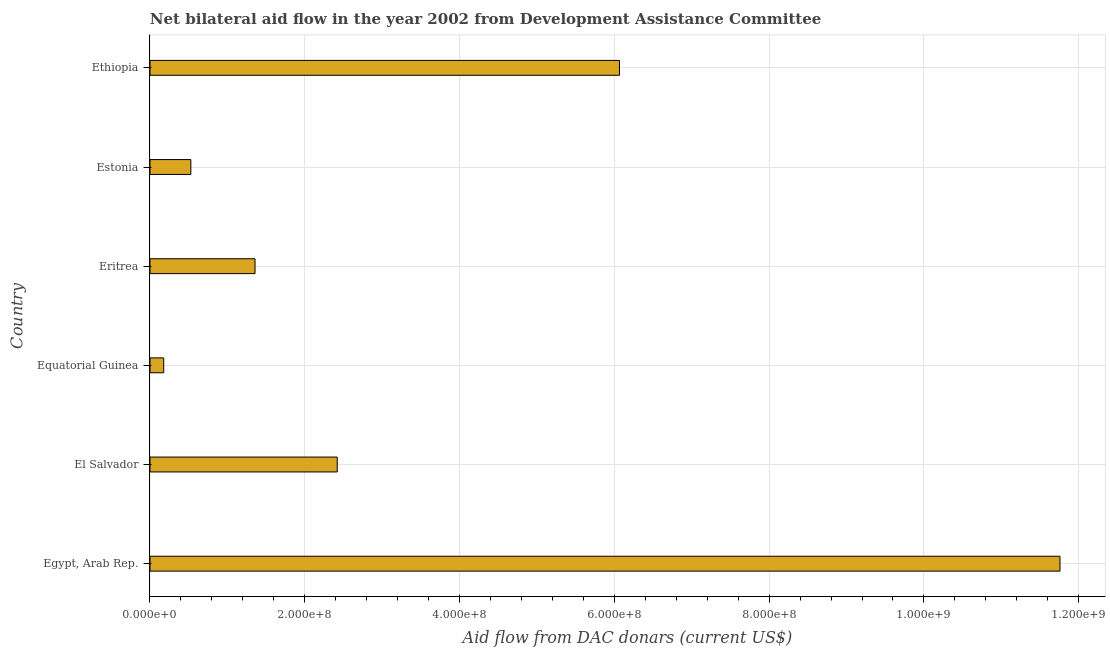What is the title of the graph?
Your response must be concise. Net bilateral aid flow in the year 2002 from Development Assistance Committee. What is the label or title of the X-axis?
Provide a short and direct response. Aid flow from DAC donars (current US$). What is the net bilateral aid flows from dac donors in Ethiopia?
Keep it short and to the point. 6.07e+08. Across all countries, what is the maximum net bilateral aid flows from dac donors?
Provide a succinct answer. 1.18e+09. Across all countries, what is the minimum net bilateral aid flows from dac donors?
Offer a terse response. 1.77e+07. In which country was the net bilateral aid flows from dac donors maximum?
Provide a short and direct response. Egypt, Arab Rep. In which country was the net bilateral aid flows from dac donors minimum?
Give a very brief answer. Equatorial Guinea. What is the sum of the net bilateral aid flows from dac donors?
Offer a terse response. 2.23e+09. What is the difference between the net bilateral aid flows from dac donors in Equatorial Guinea and Estonia?
Give a very brief answer. -3.50e+07. What is the average net bilateral aid flows from dac donors per country?
Keep it short and to the point. 3.72e+08. What is the median net bilateral aid flows from dac donors?
Ensure brevity in your answer.  1.89e+08. What is the ratio of the net bilateral aid flows from dac donors in Equatorial Guinea to that in Eritrea?
Your answer should be very brief. 0.13. What is the difference between the highest and the second highest net bilateral aid flows from dac donors?
Your response must be concise. 5.69e+08. What is the difference between the highest and the lowest net bilateral aid flows from dac donors?
Your response must be concise. 1.16e+09. In how many countries, is the net bilateral aid flows from dac donors greater than the average net bilateral aid flows from dac donors taken over all countries?
Keep it short and to the point. 2. Are all the bars in the graph horizontal?
Offer a very short reply. Yes. How many countries are there in the graph?
Your answer should be compact. 6. What is the Aid flow from DAC donars (current US$) of Egypt, Arab Rep.?
Make the answer very short. 1.18e+09. What is the Aid flow from DAC donars (current US$) of El Salvador?
Offer a very short reply. 2.42e+08. What is the Aid flow from DAC donars (current US$) in Equatorial Guinea?
Offer a very short reply. 1.77e+07. What is the Aid flow from DAC donars (current US$) of Eritrea?
Give a very brief answer. 1.36e+08. What is the Aid flow from DAC donars (current US$) in Estonia?
Your answer should be very brief. 5.28e+07. What is the Aid flow from DAC donars (current US$) in Ethiopia?
Your answer should be very brief. 6.07e+08. What is the difference between the Aid flow from DAC donars (current US$) in Egypt, Arab Rep. and El Salvador?
Offer a very short reply. 9.34e+08. What is the difference between the Aid flow from DAC donars (current US$) in Egypt, Arab Rep. and Equatorial Guinea?
Keep it short and to the point. 1.16e+09. What is the difference between the Aid flow from DAC donars (current US$) in Egypt, Arab Rep. and Eritrea?
Make the answer very short. 1.04e+09. What is the difference between the Aid flow from DAC donars (current US$) in Egypt, Arab Rep. and Estonia?
Keep it short and to the point. 1.12e+09. What is the difference between the Aid flow from DAC donars (current US$) in Egypt, Arab Rep. and Ethiopia?
Provide a succinct answer. 5.69e+08. What is the difference between the Aid flow from DAC donars (current US$) in El Salvador and Equatorial Guinea?
Offer a terse response. 2.24e+08. What is the difference between the Aid flow from DAC donars (current US$) in El Salvador and Eritrea?
Offer a very short reply. 1.06e+08. What is the difference between the Aid flow from DAC donars (current US$) in El Salvador and Estonia?
Your response must be concise. 1.89e+08. What is the difference between the Aid flow from DAC donars (current US$) in El Salvador and Ethiopia?
Your answer should be very brief. -3.65e+08. What is the difference between the Aid flow from DAC donars (current US$) in Equatorial Guinea and Eritrea?
Ensure brevity in your answer.  -1.18e+08. What is the difference between the Aid flow from DAC donars (current US$) in Equatorial Guinea and Estonia?
Give a very brief answer. -3.50e+07. What is the difference between the Aid flow from DAC donars (current US$) in Equatorial Guinea and Ethiopia?
Ensure brevity in your answer.  -5.89e+08. What is the difference between the Aid flow from DAC donars (current US$) in Eritrea and Estonia?
Your response must be concise. 8.29e+07. What is the difference between the Aid flow from DAC donars (current US$) in Eritrea and Ethiopia?
Your answer should be compact. -4.71e+08. What is the difference between the Aid flow from DAC donars (current US$) in Estonia and Ethiopia?
Give a very brief answer. -5.54e+08. What is the ratio of the Aid flow from DAC donars (current US$) in Egypt, Arab Rep. to that in El Salvador?
Offer a very short reply. 4.86. What is the ratio of the Aid flow from DAC donars (current US$) in Egypt, Arab Rep. to that in Equatorial Guinea?
Ensure brevity in your answer.  66.32. What is the ratio of the Aid flow from DAC donars (current US$) in Egypt, Arab Rep. to that in Eritrea?
Offer a terse response. 8.66. What is the ratio of the Aid flow from DAC donars (current US$) in Egypt, Arab Rep. to that in Estonia?
Offer a terse response. 22.28. What is the ratio of the Aid flow from DAC donars (current US$) in Egypt, Arab Rep. to that in Ethiopia?
Your answer should be very brief. 1.94. What is the ratio of the Aid flow from DAC donars (current US$) in El Salvador to that in Equatorial Guinea?
Offer a terse response. 13.64. What is the ratio of the Aid flow from DAC donars (current US$) in El Salvador to that in Eritrea?
Offer a terse response. 1.78. What is the ratio of the Aid flow from DAC donars (current US$) in El Salvador to that in Estonia?
Offer a terse response. 4.58. What is the ratio of the Aid flow from DAC donars (current US$) in El Salvador to that in Ethiopia?
Provide a short and direct response. 0.4. What is the ratio of the Aid flow from DAC donars (current US$) in Equatorial Guinea to that in Eritrea?
Ensure brevity in your answer.  0.13. What is the ratio of the Aid flow from DAC donars (current US$) in Equatorial Guinea to that in Estonia?
Your answer should be compact. 0.34. What is the ratio of the Aid flow from DAC donars (current US$) in Equatorial Guinea to that in Ethiopia?
Your answer should be compact. 0.03. What is the ratio of the Aid flow from DAC donars (current US$) in Eritrea to that in Estonia?
Keep it short and to the point. 2.57. What is the ratio of the Aid flow from DAC donars (current US$) in Eritrea to that in Ethiopia?
Keep it short and to the point. 0.22. What is the ratio of the Aid flow from DAC donars (current US$) in Estonia to that in Ethiopia?
Provide a succinct answer. 0.09. 